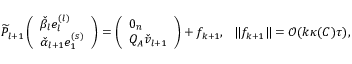Convert formula to latex. <formula><loc_0><loc_0><loc_500><loc_500>\widetilde { P } _ { l + 1 } \left ( \begin{array} { l } { \check { \beta } _ { l } e _ { l } ^ { ( l ) } } \\ { \check { \alpha } _ { l + 1 } e _ { 1 } ^ { ( s ) } } \end{array} \right ) = \left ( \begin{array} { l } { 0 _ { n } } \\ { Q _ { A } \check { v } _ { l + 1 } } \end{array} \right ) + f _ { k + 1 } , \quad | f _ { k + 1 } \| = \mathcal { O } ( k \kappa ( C ) \tau ) ,</formula> 